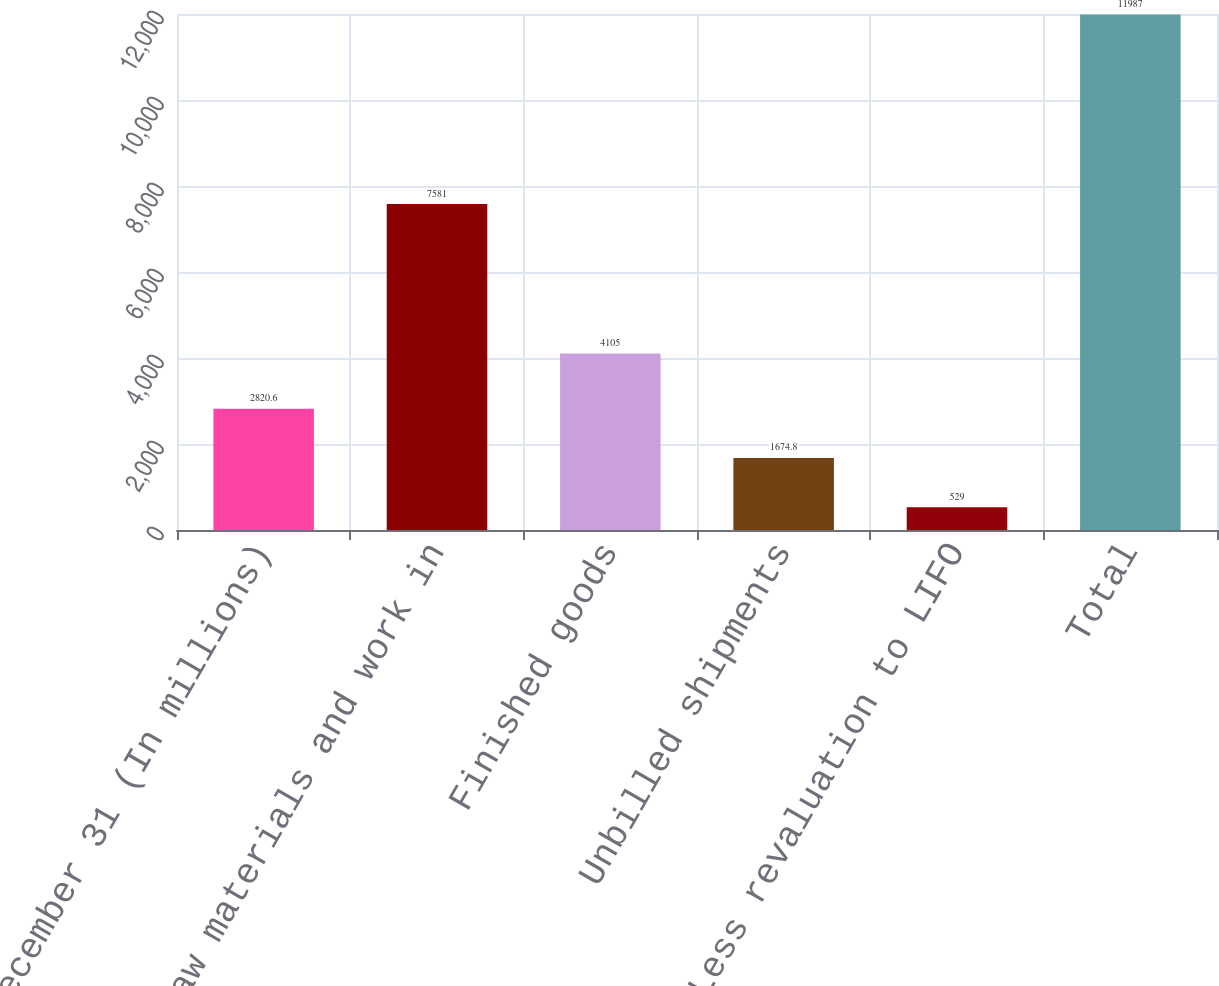<chart> <loc_0><loc_0><loc_500><loc_500><bar_chart><fcel>December 31 (In millions)<fcel>Raw materials and work in<fcel>Finished goods<fcel>Unbilled shipments<fcel>Less revaluation to LIFO<fcel>Total<nl><fcel>2820.6<fcel>7581<fcel>4105<fcel>1674.8<fcel>529<fcel>11987<nl></chart> 